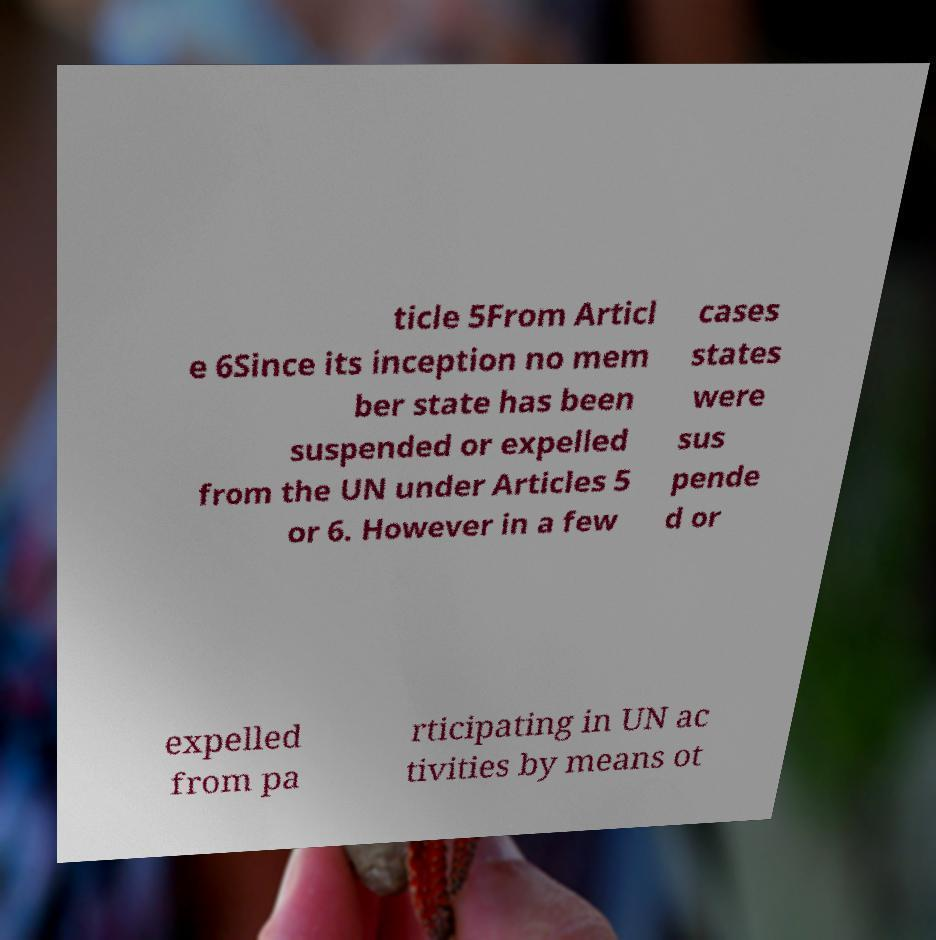What messages or text are displayed in this image? I need them in a readable, typed format. ticle 5From Articl e 6Since its inception no mem ber state has been suspended or expelled from the UN under Articles 5 or 6. However in a few cases states were sus pende d or expelled from pa rticipating in UN ac tivities by means ot 